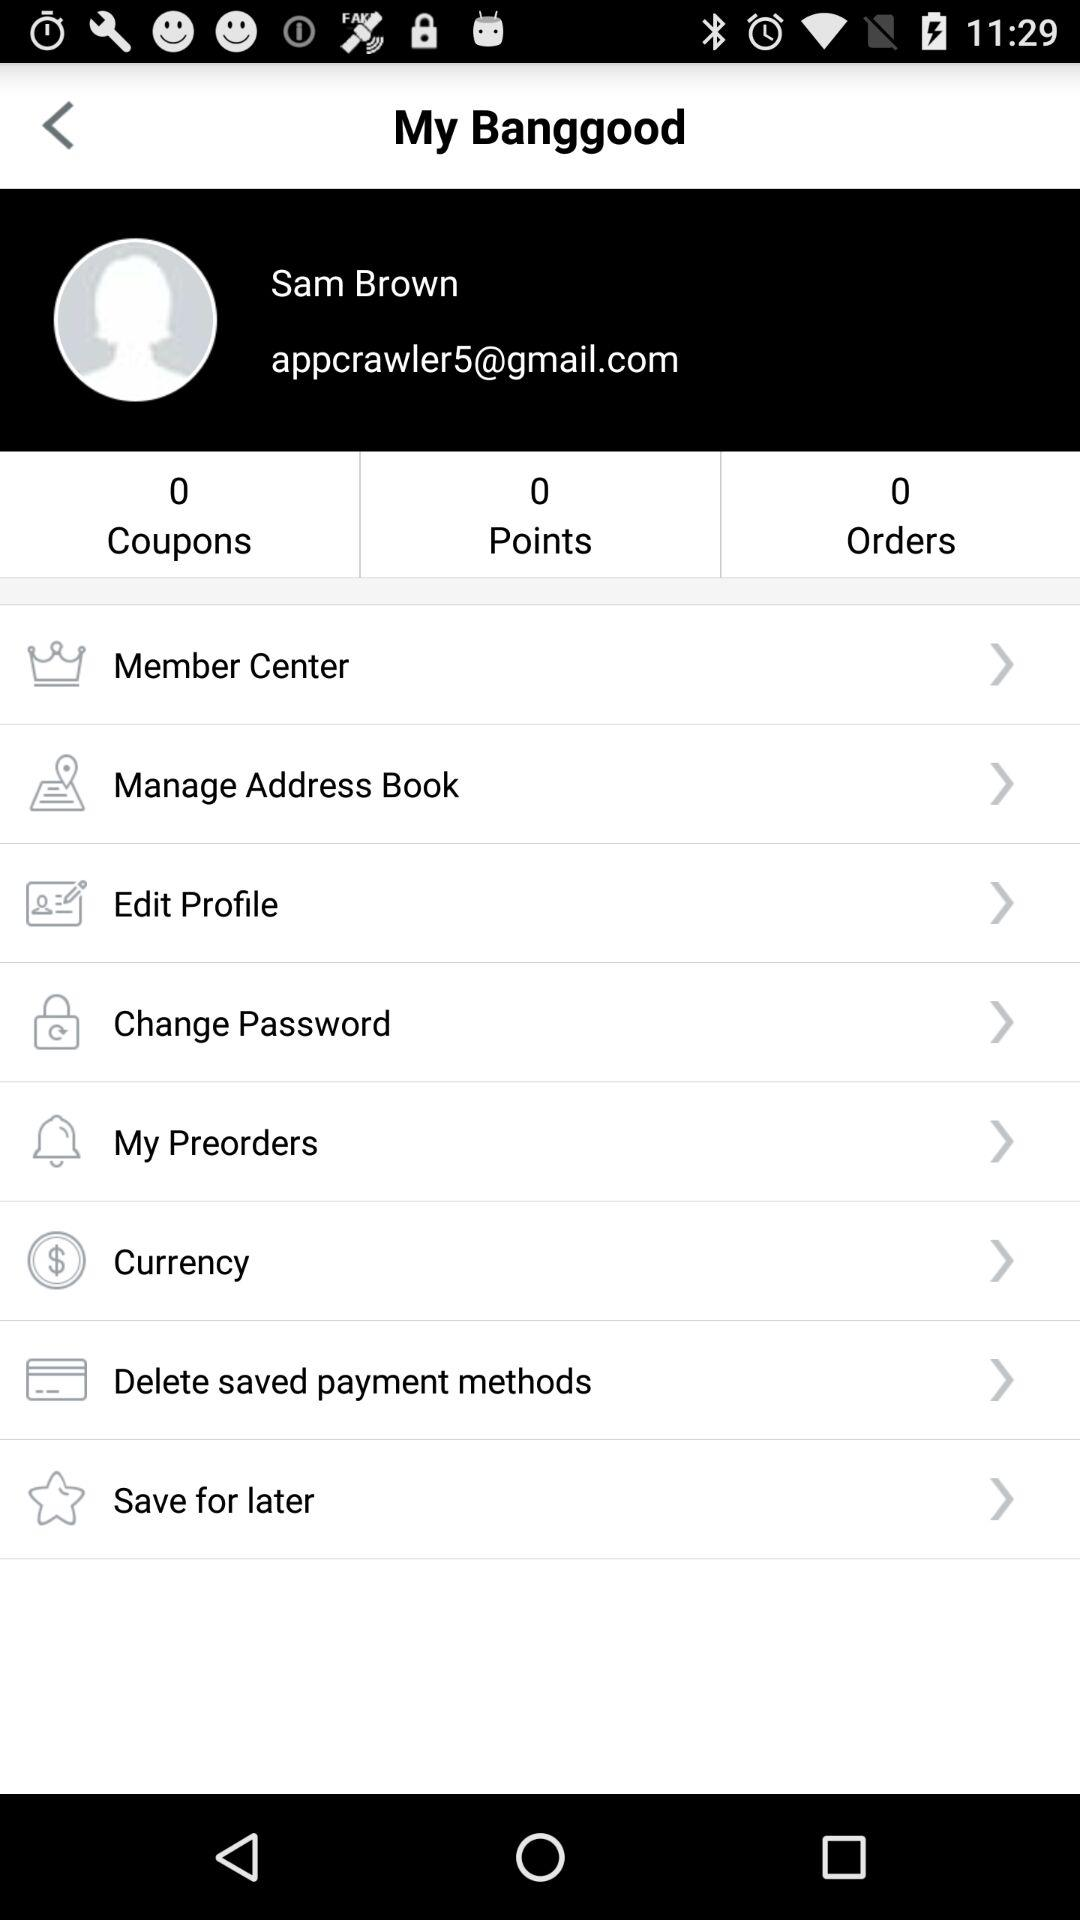What is the given user name? The given user name is Sam Brown. 